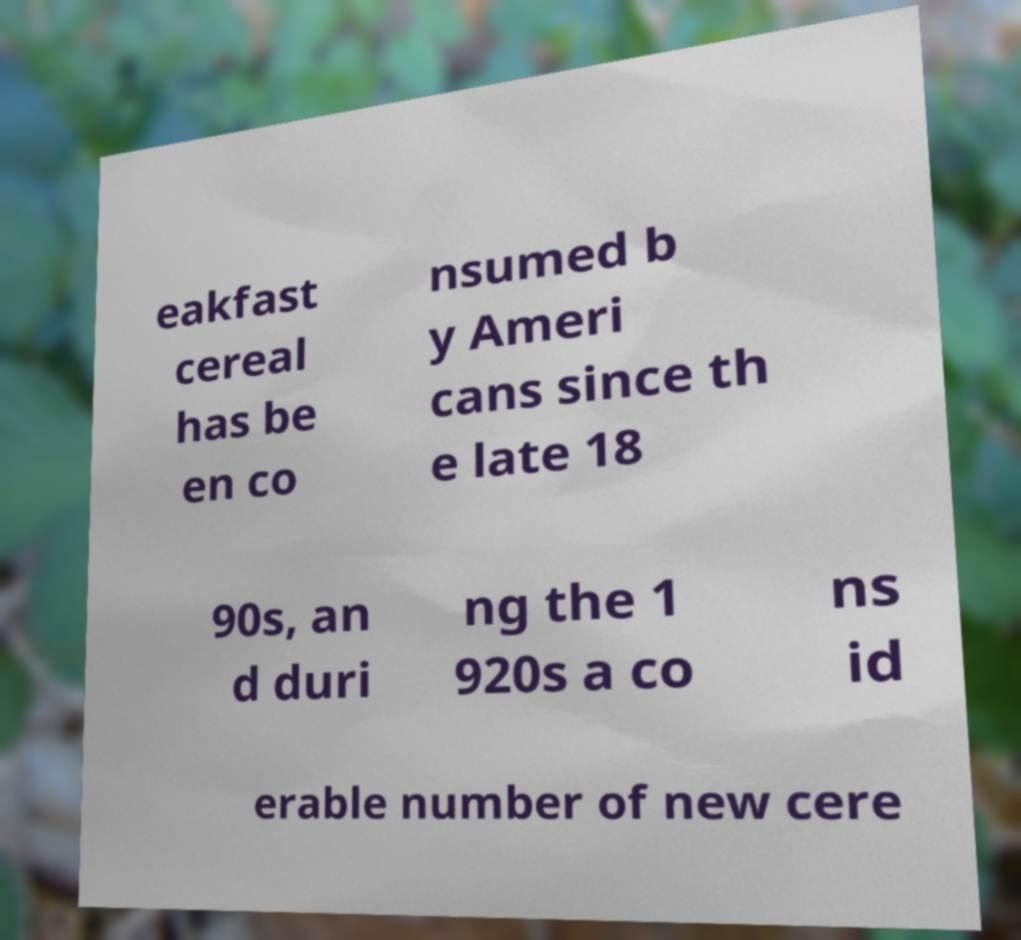Can you accurately transcribe the text from the provided image for me? eakfast cereal has be en co nsumed b y Ameri cans since th e late 18 90s, an d duri ng the 1 920s a co ns id erable number of new cere 